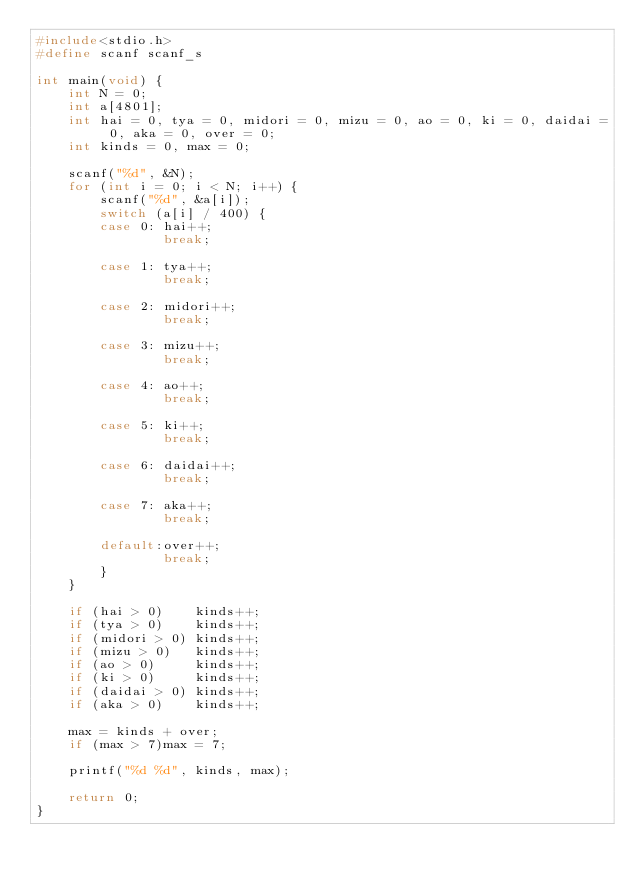Convert code to text. <code><loc_0><loc_0><loc_500><loc_500><_C_>#include<stdio.h>
#define scanf scanf_s

int main(void) {
	int N = 0;
	int a[4801];
	int hai = 0, tya = 0, midori = 0, mizu = 0, ao = 0, ki = 0, daidai = 0, aka = 0, over = 0;
	int kinds = 0, max = 0;

	scanf("%d", &N);
	for (int i = 0; i < N; i++) {
		scanf("%d", &a[i]);
		switch (a[i] / 400) {
		case 0:	hai++;
				break;

		case 1:	tya++;
				break;

		case 2:	midori++;
				break;

		case 3:	mizu++;
				break;

		case 4:	ao++;
				break;

		case 5:	ki++;
				break;

		case 6:	daidai++;
				break;

		case 7:	aka++;
				break;

		default:over++;
				break;
		}
	}

	if (hai > 0)	kinds++;
	if (tya > 0)	kinds++;
	if (midori > 0)	kinds++;
	if (mizu > 0)	kinds++;
	if (ao > 0)		kinds++;
	if (ki > 0)		kinds++;
	if (daidai > 0)	kinds++;
	if (aka > 0)	kinds++;

	max = kinds + over;
	if (max > 7)max = 7;

	printf("%d %d", kinds, max);

	return 0;
}</code> 